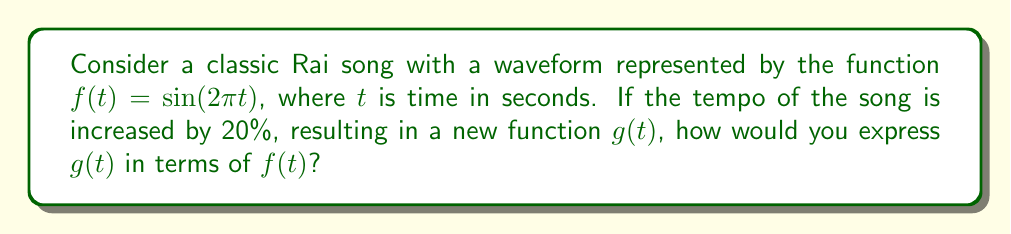Solve this math problem. Let's approach this step-by-step:

1) The original function $f(t) = \sin(2\pi t)$ represents the waveform at the original tempo.

2) Increasing the tempo by 20% means the song will play 1.2 times faster. This is equivalent to compressing the time axis horizontally.

3) To compress the time axis, we need to multiply the input variable (t) by a factor greater than 1. In this case, that factor is 1.2.

4) The new function $g(t)$ can be expressed as:

   $g(t) = f(1.2t)$

5) Substituting the original function:

   $g(t) = \sin(2\pi(1.2t))$

6) Simplifying:

   $g(t) = \sin(2.4\pi t)$

7) To express $g(t)$ in terms of $f(t)$, we need to use function composition:

   $g(t) = f(1.2t)$

This means that for any input $t$, $g(t)$ will give the same output as $f(1.2t)$. This represents a horizontal compression of the original function by a factor of 1.2, which corresponds to the 20% increase in tempo.
Answer: $g(t) = f(1.2t)$ 